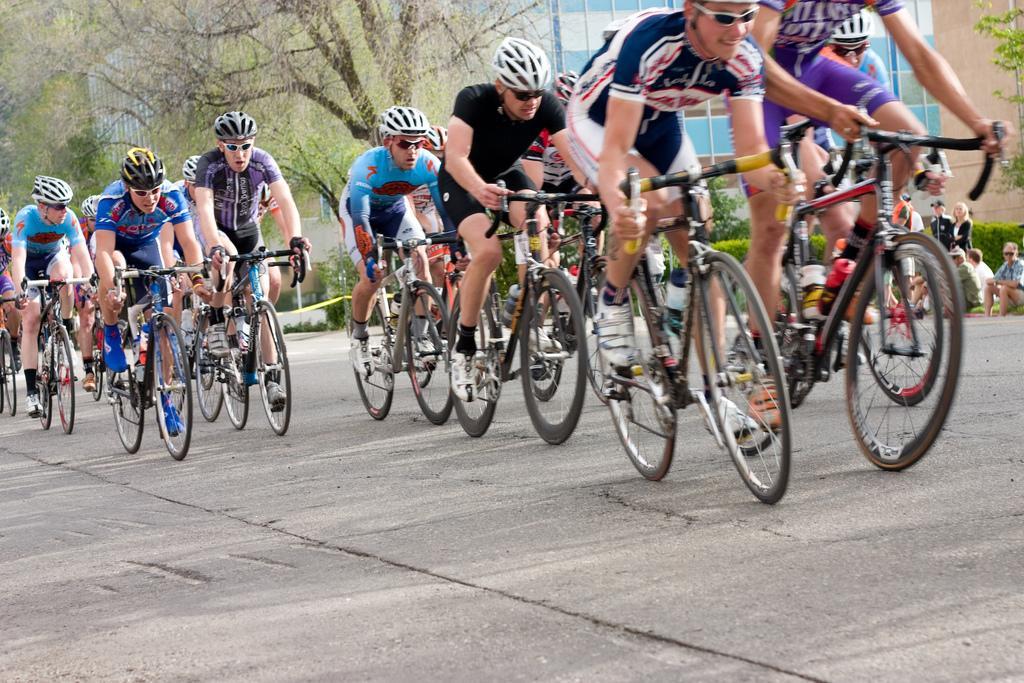How would you summarize this image in a sentence or two? In the picture we can see some people are riding a bicycle on the road and wearing a helmet and in the background, we can see some trees, buildings with a glass and some people sitting near the path. 